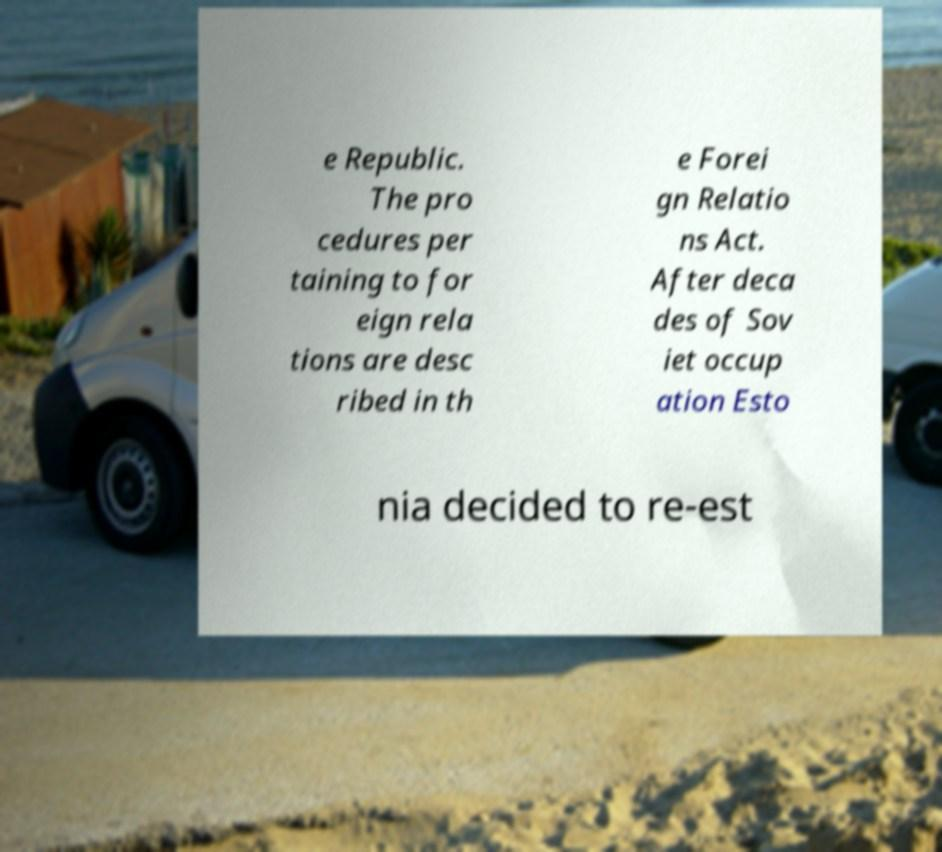Can you read and provide the text displayed in the image?This photo seems to have some interesting text. Can you extract and type it out for me? e Republic. The pro cedures per taining to for eign rela tions are desc ribed in th e Forei gn Relatio ns Act. After deca des of Sov iet occup ation Esto nia decided to re-est 